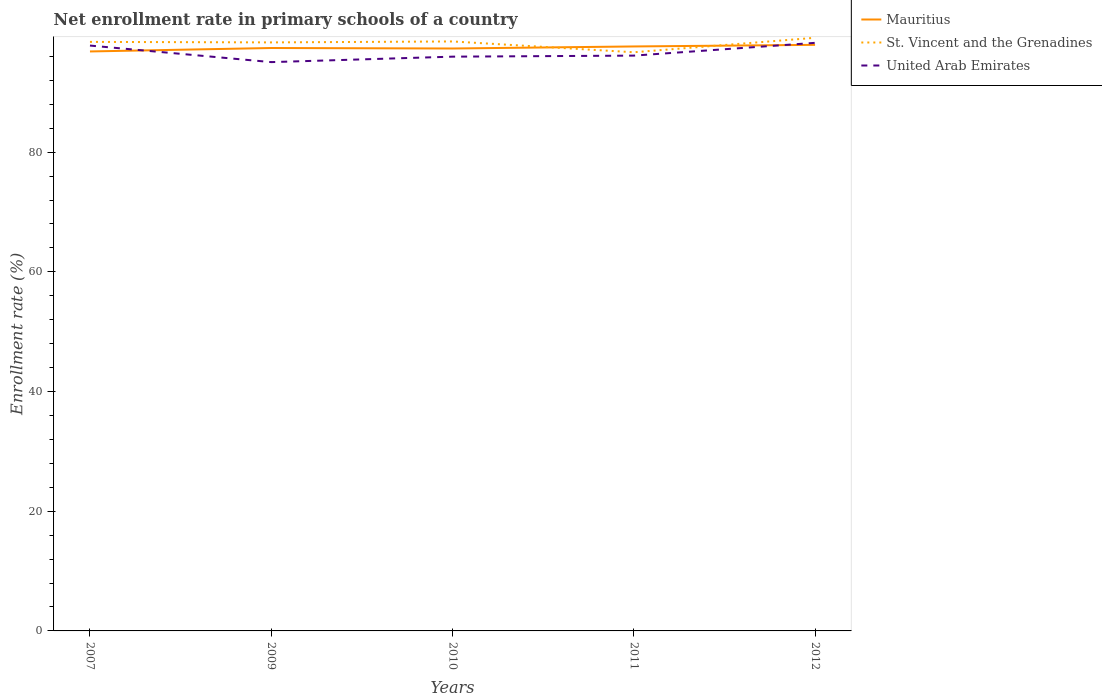Does the line corresponding to United Arab Emirates intersect with the line corresponding to Mauritius?
Give a very brief answer. Yes. Across all years, what is the maximum enrollment rate in primary schools in Mauritius?
Make the answer very short. 96.83. In which year was the enrollment rate in primary schools in United Arab Emirates maximum?
Offer a terse response. 2009. What is the total enrollment rate in primary schools in St. Vincent and the Grenadines in the graph?
Offer a terse response. -0.77. What is the difference between the highest and the second highest enrollment rate in primary schools in United Arab Emirates?
Your response must be concise. 3.22. What is the difference between the highest and the lowest enrollment rate in primary schools in St. Vincent and the Grenadines?
Your answer should be compact. 4. What is the difference between two consecutive major ticks on the Y-axis?
Your answer should be compact. 20. Does the graph contain any zero values?
Keep it short and to the point. No. What is the title of the graph?
Keep it short and to the point. Net enrollment rate in primary schools of a country. What is the label or title of the Y-axis?
Keep it short and to the point. Enrollment rate (%). What is the Enrollment rate (%) of Mauritius in 2007?
Keep it short and to the point. 96.83. What is the Enrollment rate (%) of St. Vincent and the Grenadines in 2007?
Your response must be concise. 98.43. What is the Enrollment rate (%) in United Arab Emirates in 2007?
Ensure brevity in your answer.  97.82. What is the Enrollment rate (%) in Mauritius in 2009?
Provide a short and direct response. 97.41. What is the Enrollment rate (%) of St. Vincent and the Grenadines in 2009?
Your answer should be very brief. 98.34. What is the Enrollment rate (%) of United Arab Emirates in 2009?
Provide a short and direct response. 95.05. What is the Enrollment rate (%) of Mauritius in 2010?
Your answer should be compact. 97.32. What is the Enrollment rate (%) of St. Vincent and the Grenadines in 2010?
Provide a succinct answer. 98.5. What is the Enrollment rate (%) of United Arab Emirates in 2010?
Keep it short and to the point. 95.96. What is the Enrollment rate (%) of Mauritius in 2011?
Offer a terse response. 97.67. What is the Enrollment rate (%) in St. Vincent and the Grenadines in 2011?
Make the answer very short. 96.7. What is the Enrollment rate (%) in United Arab Emirates in 2011?
Make the answer very short. 96.14. What is the Enrollment rate (%) of Mauritius in 2012?
Make the answer very short. 97.94. What is the Enrollment rate (%) in St. Vincent and the Grenadines in 2012?
Keep it short and to the point. 99.11. What is the Enrollment rate (%) in United Arab Emirates in 2012?
Your answer should be compact. 98.27. Across all years, what is the maximum Enrollment rate (%) of Mauritius?
Your answer should be very brief. 97.94. Across all years, what is the maximum Enrollment rate (%) of St. Vincent and the Grenadines?
Offer a very short reply. 99.11. Across all years, what is the maximum Enrollment rate (%) in United Arab Emirates?
Your answer should be compact. 98.27. Across all years, what is the minimum Enrollment rate (%) in Mauritius?
Your answer should be compact. 96.83. Across all years, what is the minimum Enrollment rate (%) of St. Vincent and the Grenadines?
Make the answer very short. 96.7. Across all years, what is the minimum Enrollment rate (%) of United Arab Emirates?
Your response must be concise. 95.05. What is the total Enrollment rate (%) of Mauritius in the graph?
Ensure brevity in your answer.  487.17. What is the total Enrollment rate (%) in St. Vincent and the Grenadines in the graph?
Keep it short and to the point. 491.09. What is the total Enrollment rate (%) in United Arab Emirates in the graph?
Provide a succinct answer. 483.24. What is the difference between the Enrollment rate (%) in Mauritius in 2007 and that in 2009?
Give a very brief answer. -0.58. What is the difference between the Enrollment rate (%) in St. Vincent and the Grenadines in 2007 and that in 2009?
Your answer should be very brief. 0.09. What is the difference between the Enrollment rate (%) of United Arab Emirates in 2007 and that in 2009?
Provide a short and direct response. 2.77. What is the difference between the Enrollment rate (%) in Mauritius in 2007 and that in 2010?
Give a very brief answer. -0.49. What is the difference between the Enrollment rate (%) of St. Vincent and the Grenadines in 2007 and that in 2010?
Provide a short and direct response. -0.07. What is the difference between the Enrollment rate (%) in United Arab Emirates in 2007 and that in 2010?
Provide a succinct answer. 1.85. What is the difference between the Enrollment rate (%) of Mauritius in 2007 and that in 2011?
Make the answer very short. -0.83. What is the difference between the Enrollment rate (%) of St. Vincent and the Grenadines in 2007 and that in 2011?
Your answer should be very brief. 1.73. What is the difference between the Enrollment rate (%) in United Arab Emirates in 2007 and that in 2011?
Your answer should be compact. 1.68. What is the difference between the Enrollment rate (%) of Mauritius in 2007 and that in 2012?
Ensure brevity in your answer.  -1.1. What is the difference between the Enrollment rate (%) of St. Vincent and the Grenadines in 2007 and that in 2012?
Make the answer very short. -0.68. What is the difference between the Enrollment rate (%) of United Arab Emirates in 2007 and that in 2012?
Make the answer very short. -0.45. What is the difference between the Enrollment rate (%) in Mauritius in 2009 and that in 2010?
Your answer should be compact. 0.08. What is the difference between the Enrollment rate (%) of St. Vincent and the Grenadines in 2009 and that in 2010?
Your answer should be very brief. -0.16. What is the difference between the Enrollment rate (%) in United Arab Emirates in 2009 and that in 2010?
Your answer should be compact. -0.91. What is the difference between the Enrollment rate (%) in Mauritius in 2009 and that in 2011?
Your answer should be very brief. -0.26. What is the difference between the Enrollment rate (%) in St. Vincent and the Grenadines in 2009 and that in 2011?
Provide a succinct answer. 1.65. What is the difference between the Enrollment rate (%) of United Arab Emirates in 2009 and that in 2011?
Keep it short and to the point. -1.09. What is the difference between the Enrollment rate (%) in Mauritius in 2009 and that in 2012?
Provide a short and direct response. -0.53. What is the difference between the Enrollment rate (%) in St. Vincent and the Grenadines in 2009 and that in 2012?
Your answer should be compact. -0.77. What is the difference between the Enrollment rate (%) of United Arab Emirates in 2009 and that in 2012?
Provide a succinct answer. -3.22. What is the difference between the Enrollment rate (%) of Mauritius in 2010 and that in 2011?
Keep it short and to the point. -0.34. What is the difference between the Enrollment rate (%) in St. Vincent and the Grenadines in 2010 and that in 2011?
Provide a short and direct response. 1.81. What is the difference between the Enrollment rate (%) of United Arab Emirates in 2010 and that in 2011?
Your answer should be compact. -0.17. What is the difference between the Enrollment rate (%) in Mauritius in 2010 and that in 2012?
Ensure brevity in your answer.  -0.61. What is the difference between the Enrollment rate (%) in St. Vincent and the Grenadines in 2010 and that in 2012?
Provide a short and direct response. -0.61. What is the difference between the Enrollment rate (%) in United Arab Emirates in 2010 and that in 2012?
Provide a succinct answer. -2.31. What is the difference between the Enrollment rate (%) in Mauritius in 2011 and that in 2012?
Keep it short and to the point. -0.27. What is the difference between the Enrollment rate (%) in St. Vincent and the Grenadines in 2011 and that in 2012?
Ensure brevity in your answer.  -2.42. What is the difference between the Enrollment rate (%) of United Arab Emirates in 2011 and that in 2012?
Keep it short and to the point. -2.13. What is the difference between the Enrollment rate (%) of Mauritius in 2007 and the Enrollment rate (%) of St. Vincent and the Grenadines in 2009?
Offer a very short reply. -1.51. What is the difference between the Enrollment rate (%) in Mauritius in 2007 and the Enrollment rate (%) in United Arab Emirates in 2009?
Make the answer very short. 1.78. What is the difference between the Enrollment rate (%) of St. Vincent and the Grenadines in 2007 and the Enrollment rate (%) of United Arab Emirates in 2009?
Offer a terse response. 3.38. What is the difference between the Enrollment rate (%) of Mauritius in 2007 and the Enrollment rate (%) of St. Vincent and the Grenadines in 2010?
Offer a terse response. -1.67. What is the difference between the Enrollment rate (%) in Mauritius in 2007 and the Enrollment rate (%) in United Arab Emirates in 2010?
Your answer should be very brief. 0.87. What is the difference between the Enrollment rate (%) in St. Vincent and the Grenadines in 2007 and the Enrollment rate (%) in United Arab Emirates in 2010?
Your answer should be compact. 2.47. What is the difference between the Enrollment rate (%) in Mauritius in 2007 and the Enrollment rate (%) in St. Vincent and the Grenadines in 2011?
Your answer should be very brief. 0.14. What is the difference between the Enrollment rate (%) in Mauritius in 2007 and the Enrollment rate (%) in United Arab Emirates in 2011?
Your answer should be very brief. 0.7. What is the difference between the Enrollment rate (%) in St. Vincent and the Grenadines in 2007 and the Enrollment rate (%) in United Arab Emirates in 2011?
Your answer should be compact. 2.29. What is the difference between the Enrollment rate (%) of Mauritius in 2007 and the Enrollment rate (%) of St. Vincent and the Grenadines in 2012?
Offer a very short reply. -2.28. What is the difference between the Enrollment rate (%) in Mauritius in 2007 and the Enrollment rate (%) in United Arab Emirates in 2012?
Ensure brevity in your answer.  -1.44. What is the difference between the Enrollment rate (%) of St. Vincent and the Grenadines in 2007 and the Enrollment rate (%) of United Arab Emirates in 2012?
Make the answer very short. 0.16. What is the difference between the Enrollment rate (%) of Mauritius in 2009 and the Enrollment rate (%) of St. Vincent and the Grenadines in 2010?
Keep it short and to the point. -1.09. What is the difference between the Enrollment rate (%) of Mauritius in 2009 and the Enrollment rate (%) of United Arab Emirates in 2010?
Make the answer very short. 1.45. What is the difference between the Enrollment rate (%) in St. Vincent and the Grenadines in 2009 and the Enrollment rate (%) in United Arab Emirates in 2010?
Ensure brevity in your answer.  2.38. What is the difference between the Enrollment rate (%) of Mauritius in 2009 and the Enrollment rate (%) of St. Vincent and the Grenadines in 2011?
Offer a very short reply. 0.71. What is the difference between the Enrollment rate (%) in Mauritius in 2009 and the Enrollment rate (%) in United Arab Emirates in 2011?
Ensure brevity in your answer.  1.27. What is the difference between the Enrollment rate (%) of St. Vincent and the Grenadines in 2009 and the Enrollment rate (%) of United Arab Emirates in 2011?
Ensure brevity in your answer.  2.21. What is the difference between the Enrollment rate (%) of Mauritius in 2009 and the Enrollment rate (%) of St. Vincent and the Grenadines in 2012?
Your answer should be very brief. -1.71. What is the difference between the Enrollment rate (%) in Mauritius in 2009 and the Enrollment rate (%) in United Arab Emirates in 2012?
Your response must be concise. -0.86. What is the difference between the Enrollment rate (%) in St. Vincent and the Grenadines in 2009 and the Enrollment rate (%) in United Arab Emirates in 2012?
Your answer should be very brief. 0.07. What is the difference between the Enrollment rate (%) in Mauritius in 2010 and the Enrollment rate (%) in St. Vincent and the Grenadines in 2011?
Give a very brief answer. 0.63. What is the difference between the Enrollment rate (%) of Mauritius in 2010 and the Enrollment rate (%) of United Arab Emirates in 2011?
Ensure brevity in your answer.  1.19. What is the difference between the Enrollment rate (%) in St. Vincent and the Grenadines in 2010 and the Enrollment rate (%) in United Arab Emirates in 2011?
Keep it short and to the point. 2.37. What is the difference between the Enrollment rate (%) of Mauritius in 2010 and the Enrollment rate (%) of St. Vincent and the Grenadines in 2012?
Keep it short and to the point. -1.79. What is the difference between the Enrollment rate (%) of Mauritius in 2010 and the Enrollment rate (%) of United Arab Emirates in 2012?
Provide a succinct answer. -0.94. What is the difference between the Enrollment rate (%) in St. Vincent and the Grenadines in 2010 and the Enrollment rate (%) in United Arab Emirates in 2012?
Provide a short and direct response. 0.23. What is the difference between the Enrollment rate (%) of Mauritius in 2011 and the Enrollment rate (%) of St. Vincent and the Grenadines in 2012?
Keep it short and to the point. -1.45. What is the difference between the Enrollment rate (%) in Mauritius in 2011 and the Enrollment rate (%) in United Arab Emirates in 2012?
Ensure brevity in your answer.  -0.6. What is the difference between the Enrollment rate (%) of St. Vincent and the Grenadines in 2011 and the Enrollment rate (%) of United Arab Emirates in 2012?
Your answer should be very brief. -1.57. What is the average Enrollment rate (%) in Mauritius per year?
Give a very brief answer. 97.43. What is the average Enrollment rate (%) of St. Vincent and the Grenadines per year?
Your answer should be compact. 98.22. What is the average Enrollment rate (%) of United Arab Emirates per year?
Give a very brief answer. 96.65. In the year 2007, what is the difference between the Enrollment rate (%) of Mauritius and Enrollment rate (%) of St. Vincent and the Grenadines?
Offer a terse response. -1.6. In the year 2007, what is the difference between the Enrollment rate (%) in Mauritius and Enrollment rate (%) in United Arab Emirates?
Your answer should be very brief. -0.98. In the year 2007, what is the difference between the Enrollment rate (%) of St. Vincent and the Grenadines and Enrollment rate (%) of United Arab Emirates?
Give a very brief answer. 0.61. In the year 2009, what is the difference between the Enrollment rate (%) of Mauritius and Enrollment rate (%) of St. Vincent and the Grenadines?
Make the answer very short. -0.94. In the year 2009, what is the difference between the Enrollment rate (%) in Mauritius and Enrollment rate (%) in United Arab Emirates?
Provide a succinct answer. 2.36. In the year 2009, what is the difference between the Enrollment rate (%) in St. Vincent and the Grenadines and Enrollment rate (%) in United Arab Emirates?
Offer a terse response. 3.29. In the year 2010, what is the difference between the Enrollment rate (%) of Mauritius and Enrollment rate (%) of St. Vincent and the Grenadines?
Make the answer very short. -1.18. In the year 2010, what is the difference between the Enrollment rate (%) of Mauritius and Enrollment rate (%) of United Arab Emirates?
Provide a succinct answer. 1.36. In the year 2010, what is the difference between the Enrollment rate (%) of St. Vincent and the Grenadines and Enrollment rate (%) of United Arab Emirates?
Your answer should be very brief. 2.54. In the year 2011, what is the difference between the Enrollment rate (%) of Mauritius and Enrollment rate (%) of St. Vincent and the Grenadines?
Keep it short and to the point. 0.97. In the year 2011, what is the difference between the Enrollment rate (%) in Mauritius and Enrollment rate (%) in United Arab Emirates?
Your answer should be very brief. 1.53. In the year 2011, what is the difference between the Enrollment rate (%) of St. Vincent and the Grenadines and Enrollment rate (%) of United Arab Emirates?
Your answer should be very brief. 0.56. In the year 2012, what is the difference between the Enrollment rate (%) of Mauritius and Enrollment rate (%) of St. Vincent and the Grenadines?
Your response must be concise. -1.18. In the year 2012, what is the difference between the Enrollment rate (%) of Mauritius and Enrollment rate (%) of United Arab Emirates?
Offer a very short reply. -0.33. In the year 2012, what is the difference between the Enrollment rate (%) in St. Vincent and the Grenadines and Enrollment rate (%) in United Arab Emirates?
Offer a terse response. 0.84. What is the ratio of the Enrollment rate (%) in United Arab Emirates in 2007 to that in 2009?
Keep it short and to the point. 1.03. What is the ratio of the Enrollment rate (%) in St. Vincent and the Grenadines in 2007 to that in 2010?
Keep it short and to the point. 1. What is the ratio of the Enrollment rate (%) of United Arab Emirates in 2007 to that in 2010?
Ensure brevity in your answer.  1.02. What is the ratio of the Enrollment rate (%) of St. Vincent and the Grenadines in 2007 to that in 2011?
Your response must be concise. 1.02. What is the ratio of the Enrollment rate (%) in United Arab Emirates in 2007 to that in 2011?
Make the answer very short. 1.02. What is the ratio of the Enrollment rate (%) in Mauritius in 2007 to that in 2012?
Provide a short and direct response. 0.99. What is the ratio of the Enrollment rate (%) of United Arab Emirates in 2007 to that in 2012?
Your response must be concise. 1. What is the ratio of the Enrollment rate (%) in Mauritius in 2009 to that in 2010?
Offer a terse response. 1. What is the ratio of the Enrollment rate (%) of United Arab Emirates in 2009 to that in 2010?
Your answer should be very brief. 0.99. What is the ratio of the Enrollment rate (%) in Mauritius in 2009 to that in 2011?
Offer a very short reply. 1. What is the ratio of the Enrollment rate (%) of United Arab Emirates in 2009 to that in 2011?
Provide a succinct answer. 0.99. What is the ratio of the Enrollment rate (%) of United Arab Emirates in 2009 to that in 2012?
Your answer should be very brief. 0.97. What is the ratio of the Enrollment rate (%) of Mauritius in 2010 to that in 2011?
Your answer should be compact. 1. What is the ratio of the Enrollment rate (%) in St. Vincent and the Grenadines in 2010 to that in 2011?
Your answer should be very brief. 1.02. What is the ratio of the Enrollment rate (%) of Mauritius in 2010 to that in 2012?
Your answer should be compact. 0.99. What is the ratio of the Enrollment rate (%) of United Arab Emirates in 2010 to that in 2012?
Make the answer very short. 0.98. What is the ratio of the Enrollment rate (%) of Mauritius in 2011 to that in 2012?
Offer a terse response. 1. What is the ratio of the Enrollment rate (%) of St. Vincent and the Grenadines in 2011 to that in 2012?
Your response must be concise. 0.98. What is the ratio of the Enrollment rate (%) in United Arab Emirates in 2011 to that in 2012?
Make the answer very short. 0.98. What is the difference between the highest and the second highest Enrollment rate (%) of Mauritius?
Make the answer very short. 0.27. What is the difference between the highest and the second highest Enrollment rate (%) of St. Vincent and the Grenadines?
Offer a very short reply. 0.61. What is the difference between the highest and the second highest Enrollment rate (%) in United Arab Emirates?
Ensure brevity in your answer.  0.45. What is the difference between the highest and the lowest Enrollment rate (%) of Mauritius?
Your answer should be very brief. 1.1. What is the difference between the highest and the lowest Enrollment rate (%) in St. Vincent and the Grenadines?
Ensure brevity in your answer.  2.42. What is the difference between the highest and the lowest Enrollment rate (%) in United Arab Emirates?
Keep it short and to the point. 3.22. 